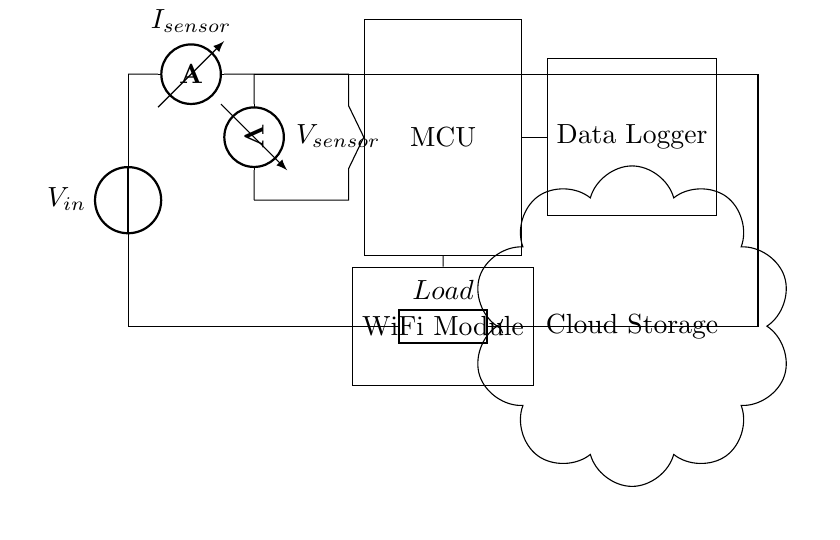what is the main power source in this circuit? The main power source is labeled as V_in in the diagram. It supplies energy to the entire circuit.
Answer: V_in how many sensors are present in this circuit? There are two sensors in the circuit: one current sensor and one voltage sensor. This can be counted from the components labeled "I_sensor" and "V_sensor".
Answer: two what type of microcontroller is used in this circuit? The circuit does not specify a type; it is labeled simply as MCU. Therefore, we cannot determine the specific type from the diagram itself.
Answer: MCU how does the microcontroller connect to the data logger? The microcontroller is connected to the data logger with a straight line, which indicates a data connection, and this connection is labeled simply with an arrow indicating data flow.
Answer: straight line what is the function of the WiFi module in this circuit? The WiFi module enables wireless communication, most likely to send data to the cloud storage. This can be inferred from its position and connection to cloud storage.
Answer: wireless communication what is the load in this circuit? The load in the circuit is represented by a generic component labeled "Load." It indicates the part of the circuit consuming energy, as shown at the bottom of the circuit diagram.
Answer: Load how does data transfer occur in the system? Data transfer occurs from the microcontroller to the data logger, and then from the WiFi module to cloud storage. The connections shown indicate the direction of data flow clearly through arrows and lines.
Answer: microcontroller to data logger to cloud storage 